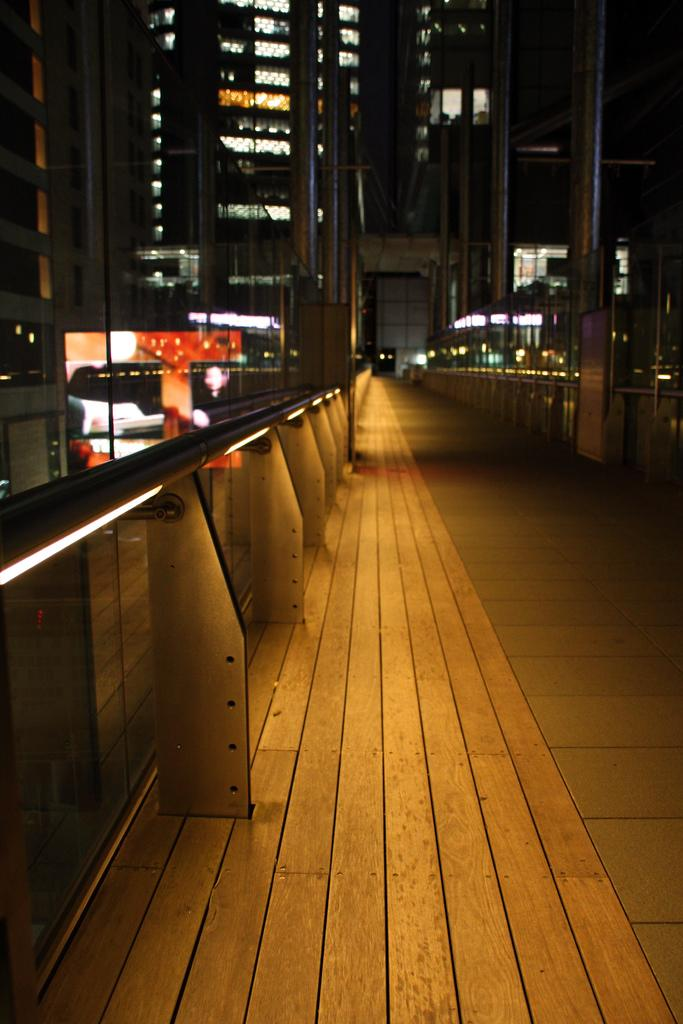What type of structures can be seen in the image? There are railings, poles, and buildings in the image. What else is present in the image besides these structures? There are lights in the image. Can you describe the purpose of the railings and poles in the image? The railings and poles may serve as support or guidance for people or vehicles. Where is the calendar located in the image? There is no calendar present in the image. Can you tell me how many goldfish are swimming in the image? There are no goldfish present in the image. 